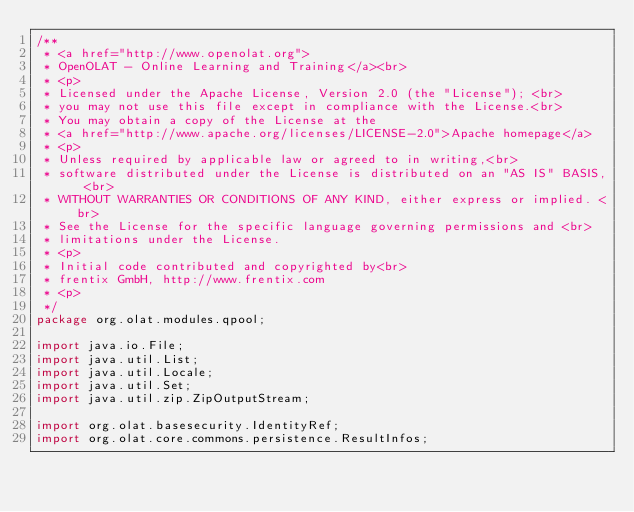<code> <loc_0><loc_0><loc_500><loc_500><_Java_>/**
 * <a href="http://www.openolat.org">
 * OpenOLAT - Online Learning and Training</a><br>
 * <p>
 * Licensed under the Apache License, Version 2.0 (the "License"); <br>
 * you may not use this file except in compliance with the License.<br>
 * You may obtain a copy of the License at the
 * <a href="http://www.apache.org/licenses/LICENSE-2.0">Apache homepage</a>
 * <p>
 * Unless required by applicable law or agreed to in writing,<br>
 * software distributed under the License is distributed on an "AS IS" BASIS, <br>
 * WITHOUT WARRANTIES OR CONDITIONS OF ANY KIND, either express or implied. <br>
 * See the License for the specific language governing permissions and <br>
 * limitations under the License.
 * <p>
 * Initial code contributed and copyrighted by<br>
 * frentix GmbH, http://www.frentix.com
 * <p>
 */
package org.olat.modules.qpool;

import java.io.File;
import java.util.List;
import java.util.Locale;
import java.util.Set;
import java.util.zip.ZipOutputStream;

import org.olat.basesecurity.IdentityRef;
import org.olat.core.commons.persistence.ResultInfos;</code> 